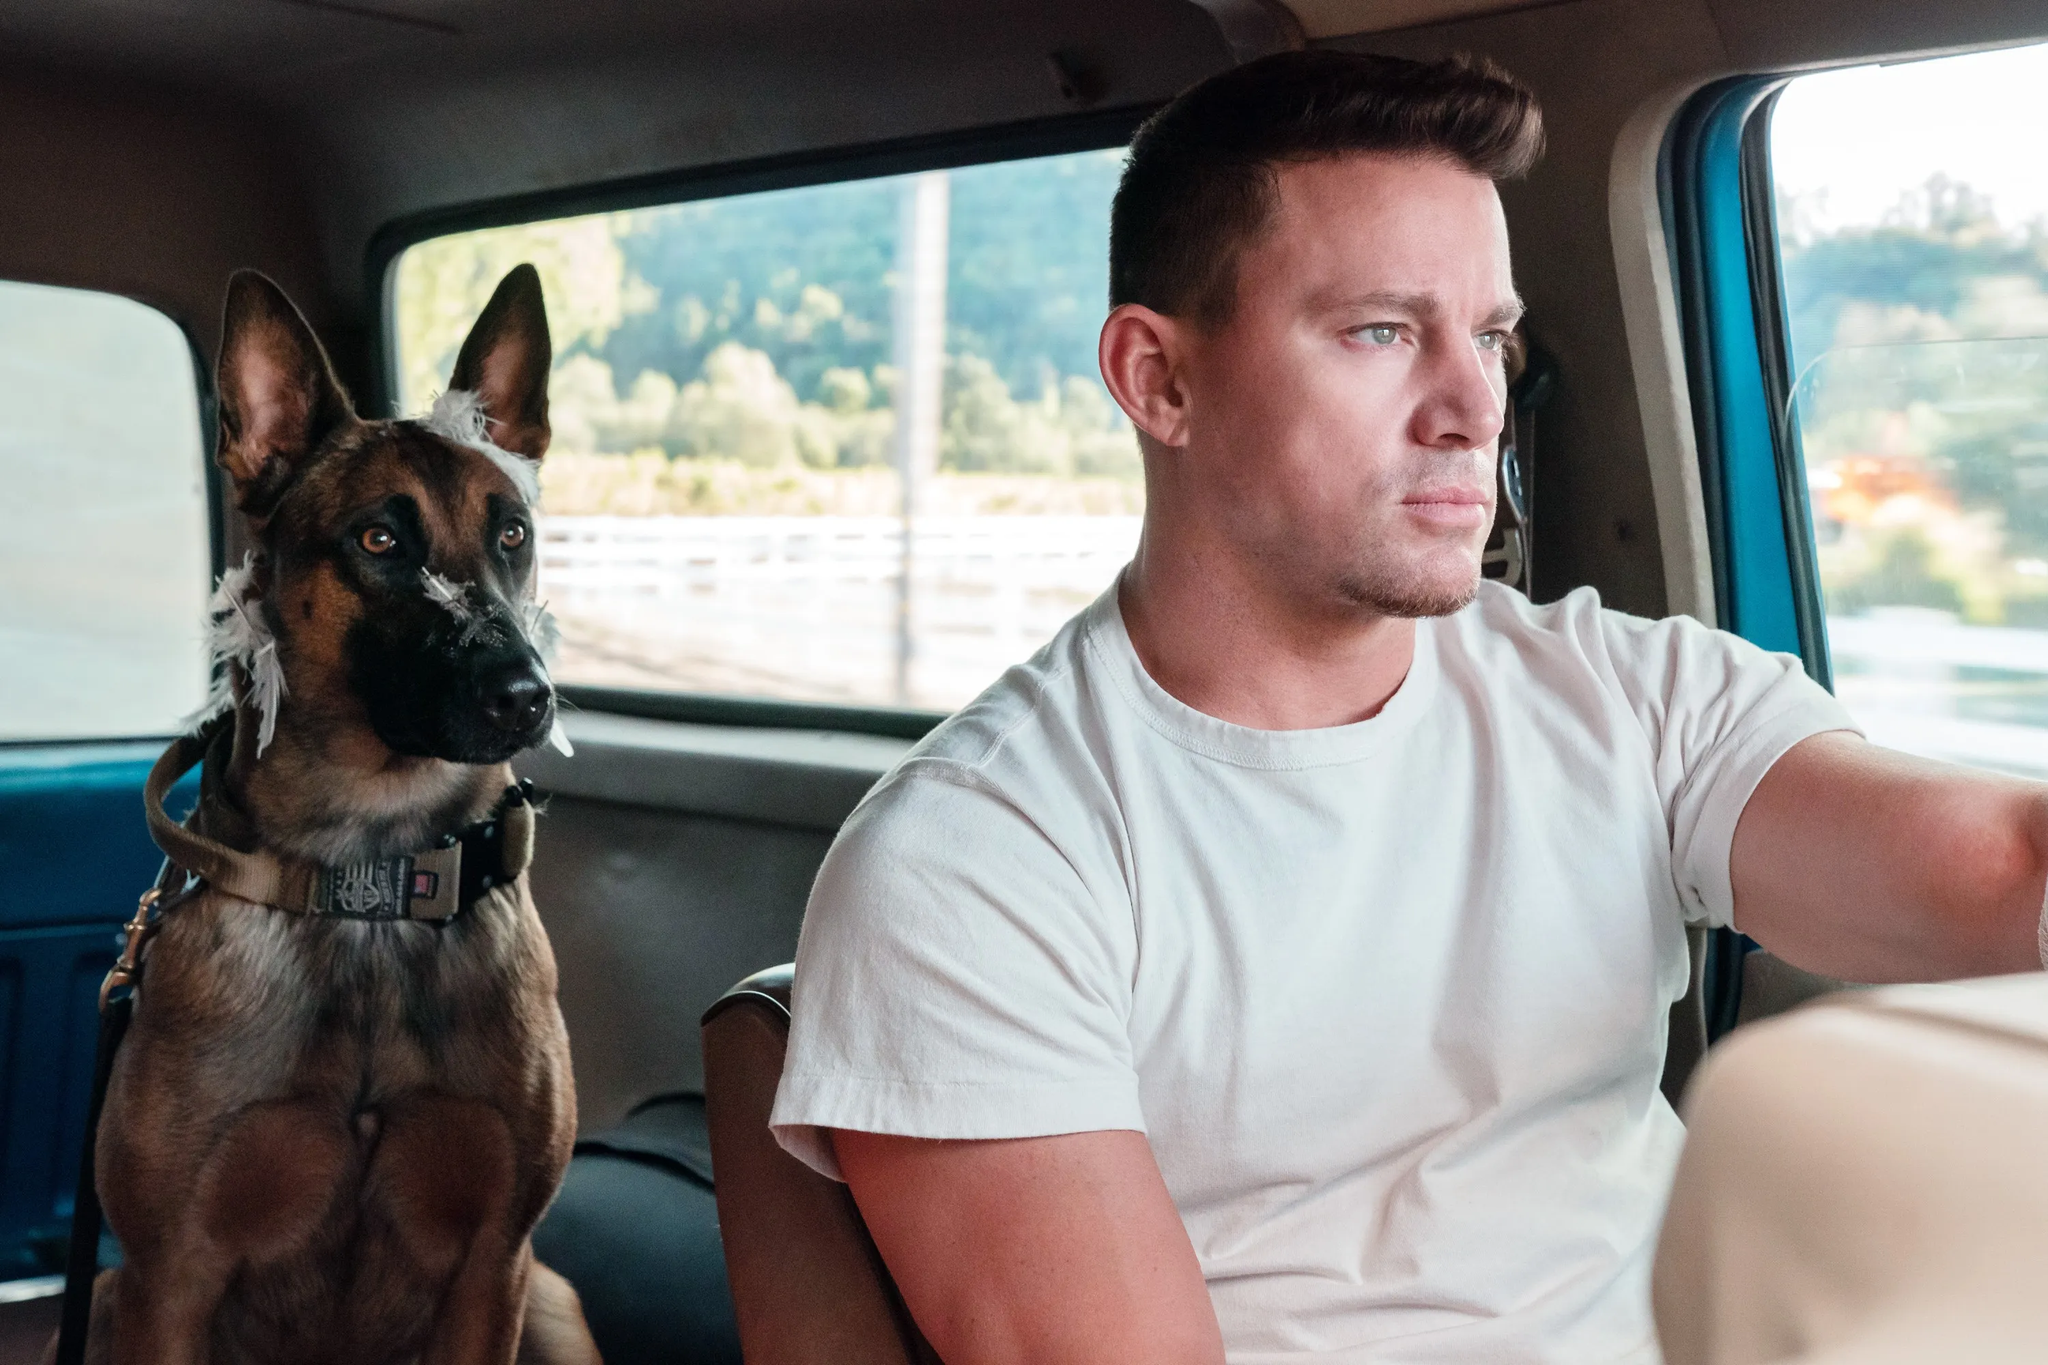Can you describe the main features of this image for me? In this image, a man is driving a car, sitting in the driver's seat, focusing on the road ahead. He is dressed casually in a white t-shirt, giving off a relaxed vibe. In the passenger seat, there is a brown dog with a black collar adorned with a patch of white fur around its eyes and ears, looking attentively ahead. The background displays a blurred view of trees and the road, suggesting movement and a sense of travel. This snapshot evokes a sense of calm and companionship during a road trip. 